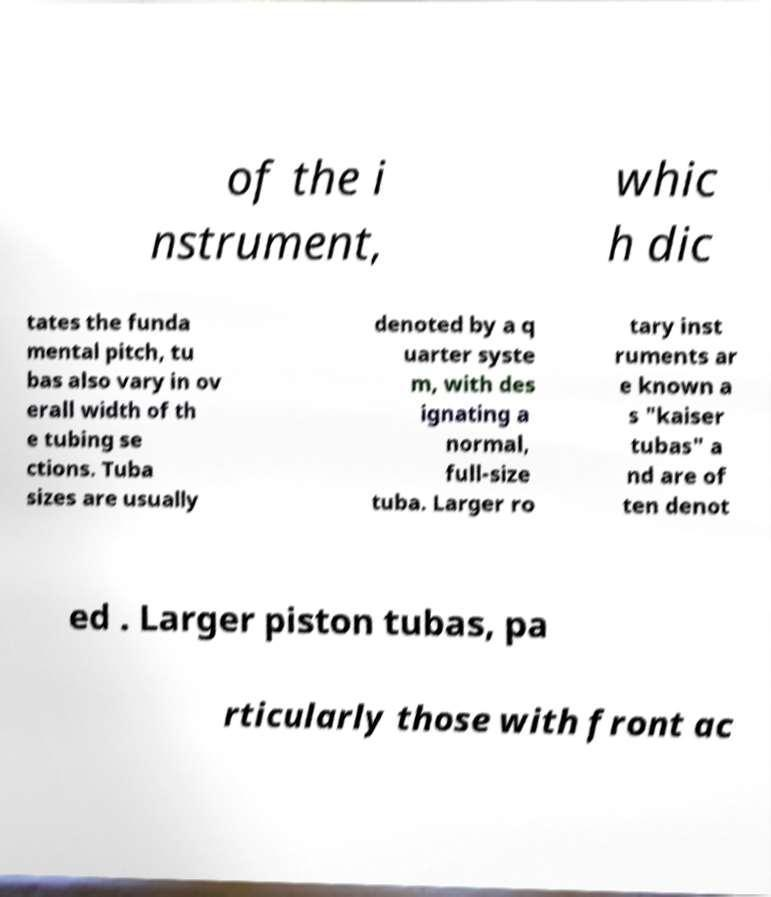For documentation purposes, I need the text within this image transcribed. Could you provide that? of the i nstrument, whic h dic tates the funda mental pitch, tu bas also vary in ov erall width of th e tubing se ctions. Tuba sizes are usually denoted by a q uarter syste m, with des ignating a normal, full-size tuba. Larger ro tary inst ruments ar e known a s "kaiser tubas" a nd are of ten denot ed . Larger piston tubas, pa rticularly those with front ac 